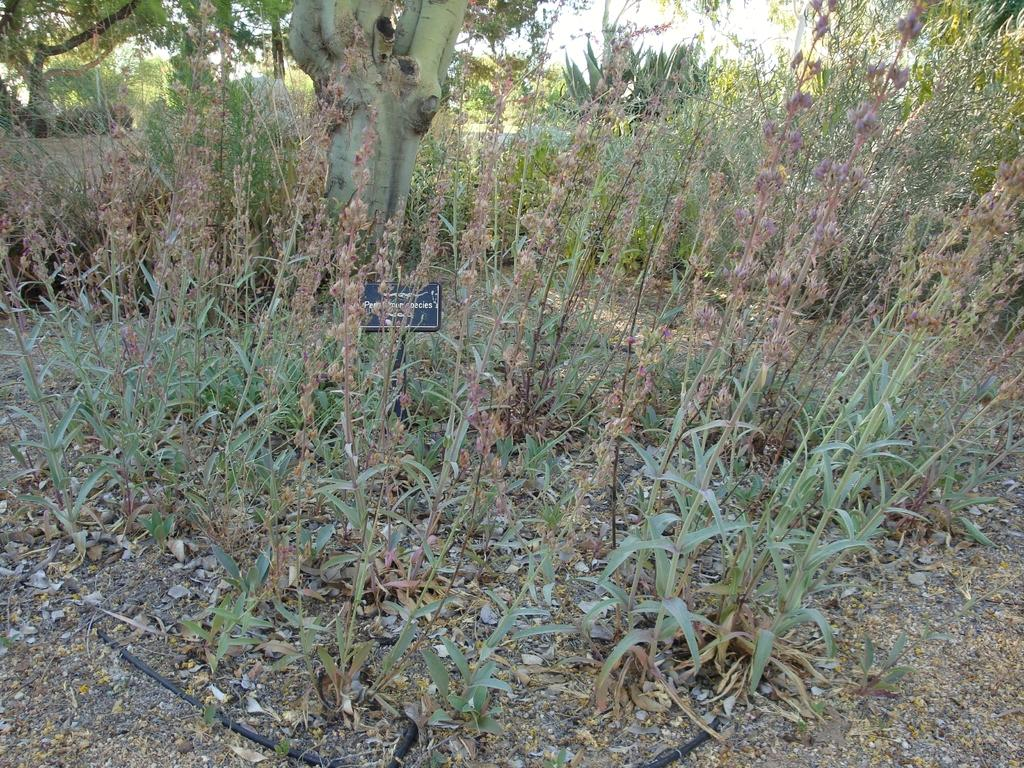What is attached to the pole in the image? There is a board attached to the pole in the image. Where is the pole located? The pole is on the land. What type of vegetation can be seen on the land? There are plants and trees on the land. What color is the shirt worn by the deer in the image? There is no deer or shirt present in the image. How many clovers can be seen growing on the land in the image? There is no mention of clovers in the image; only plants and trees are mentioned. 